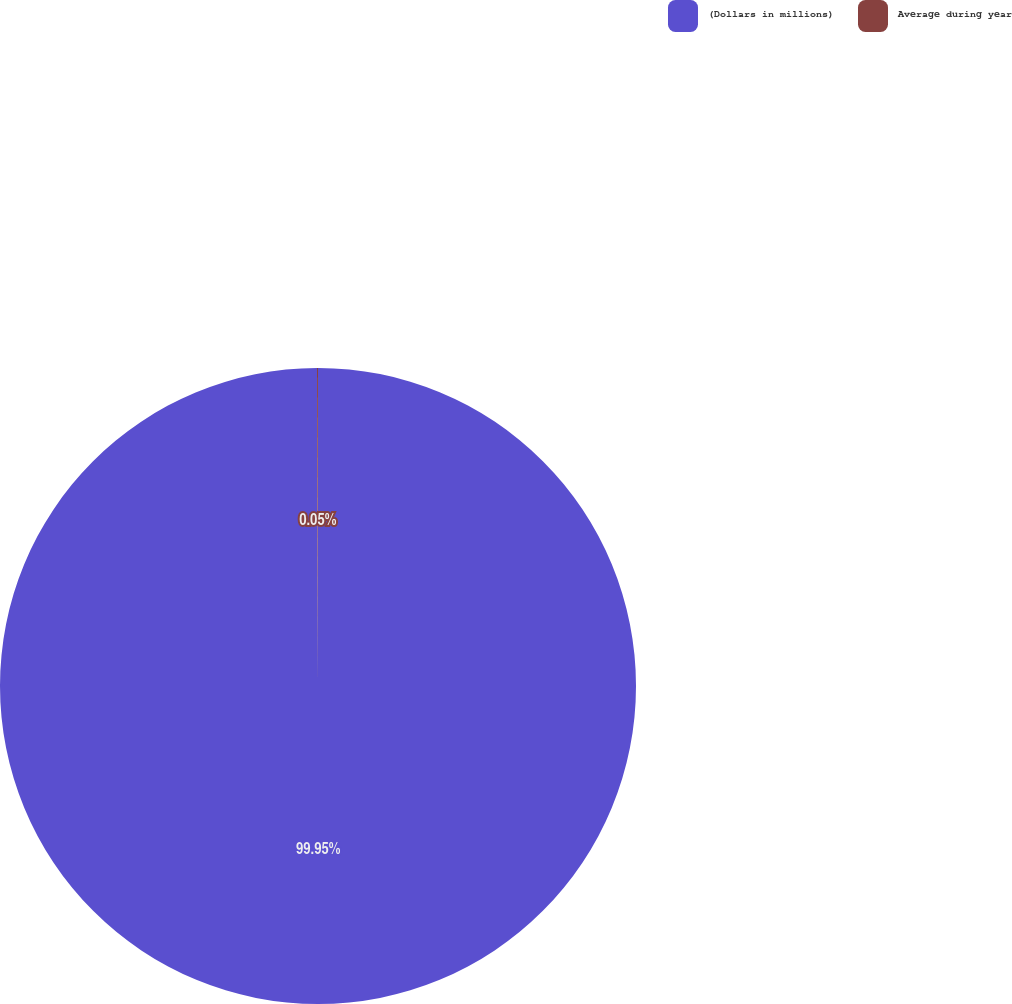<chart> <loc_0><loc_0><loc_500><loc_500><pie_chart><fcel>(Dollars in millions)<fcel>Average during year<nl><fcel>99.95%<fcel>0.05%<nl></chart> 